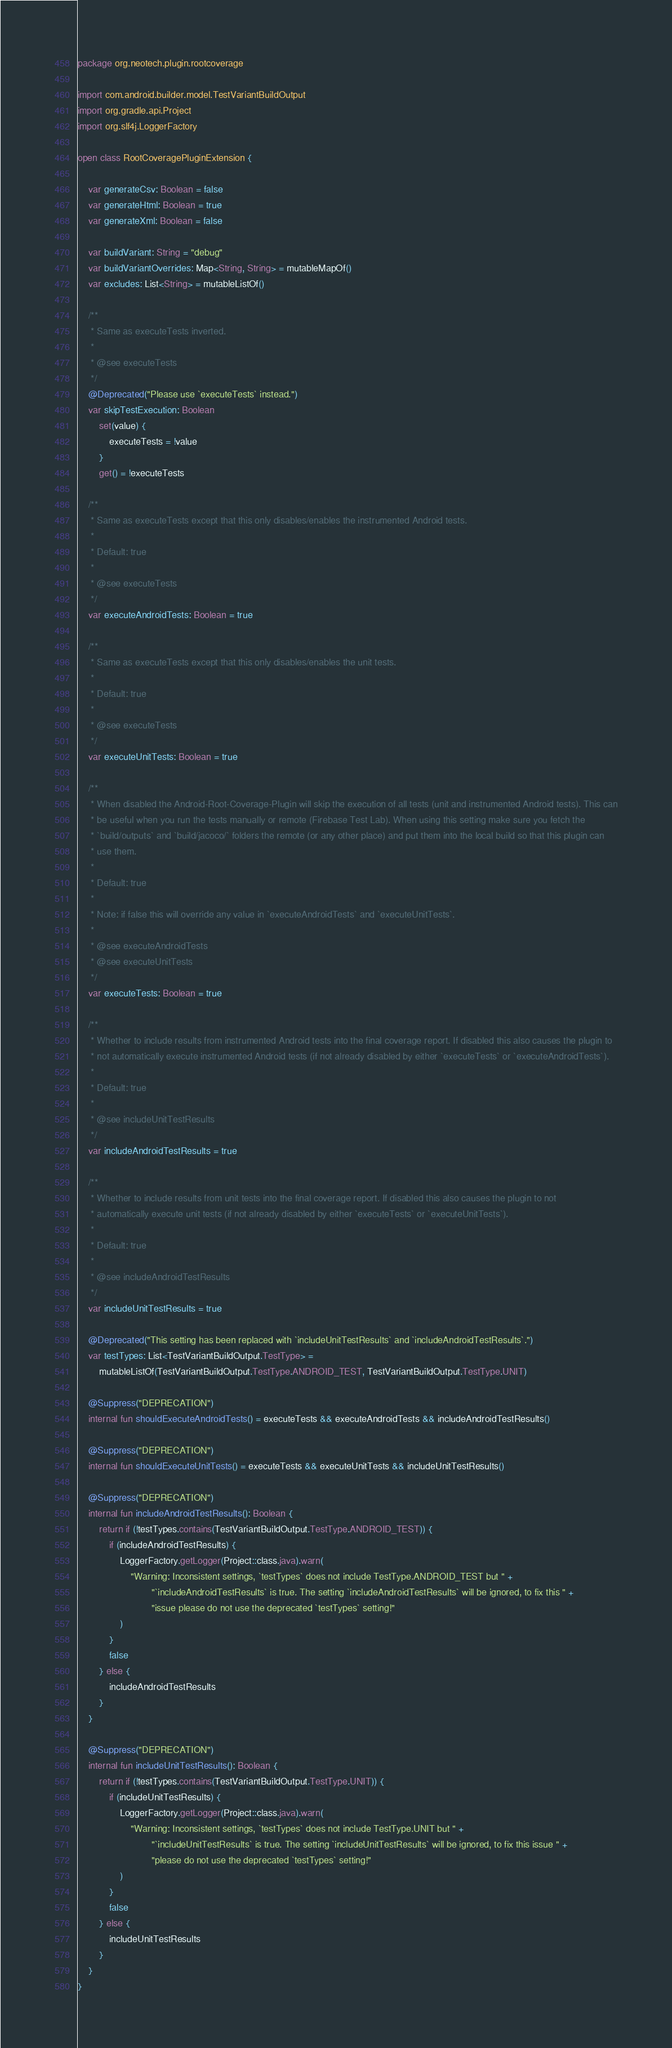Convert code to text. <code><loc_0><loc_0><loc_500><loc_500><_Kotlin_>package org.neotech.plugin.rootcoverage

import com.android.builder.model.TestVariantBuildOutput
import org.gradle.api.Project
import org.slf4j.LoggerFactory

open class RootCoveragePluginExtension {

    var generateCsv: Boolean = false
    var generateHtml: Boolean = true
    var generateXml: Boolean = false

    var buildVariant: String = "debug"
    var buildVariantOverrides: Map<String, String> = mutableMapOf()
    var excludes: List<String> = mutableListOf()

    /**
     * Same as executeTests inverted.
     *
     * @see executeTests
     */
    @Deprecated("Please use `executeTests` instead.")
    var skipTestExecution: Boolean
        set(value) {
            executeTests = !value
        }
        get() = !executeTests

    /**
     * Same as executeTests except that this only disables/enables the instrumented Android tests.
     *
     * Default: true
     *
     * @see executeTests
     */
    var executeAndroidTests: Boolean = true

    /**
     * Same as executeTests except that this only disables/enables the unit tests.
     *
     * Default: true
     *
     * @see executeTests
     */
    var executeUnitTests: Boolean = true

    /**
     * When disabled the Android-Root-Coverage-Plugin will skip the execution of all tests (unit and instrumented Android tests). This can
     * be useful when you run the tests manually or remote (Firebase Test Lab). When using this setting make sure you fetch the
     * `build/outputs` and `build/jacoco/` folders the remote (or any other place) and put them into the local build so that this plugin can
     * use them.
     *
     * Default: true
     *
     * Note: if false this will override any value in `executeAndroidTests` and `executeUnitTests`.
     *
     * @see executeAndroidTests
     * @see executeUnitTests
     */
    var executeTests: Boolean = true

    /**
     * Whether to include results from instrumented Android tests into the final coverage report. If disabled this also causes the plugin to
     * not automatically execute instrumented Android tests (if not already disabled by either `executeTests` or `executeAndroidTests`).
     *
     * Default: true
     *
     * @see includeUnitTestResults
     */
    var includeAndroidTestResults = true

    /**
     * Whether to include results from unit tests into the final coverage report. If disabled this also causes the plugin to not
     * automatically execute unit tests (if not already disabled by either `executeTests` or `executeUnitTests`).
     *
     * Default: true
     *
     * @see includeAndroidTestResults
     */
    var includeUnitTestResults = true

    @Deprecated("This setting has been replaced with `includeUnitTestResults` and `includeAndroidTestResults`.")
    var testTypes: List<TestVariantBuildOutput.TestType> =
        mutableListOf(TestVariantBuildOutput.TestType.ANDROID_TEST, TestVariantBuildOutput.TestType.UNIT)

    @Suppress("DEPRECATION")
    internal fun shouldExecuteAndroidTests() = executeTests && executeAndroidTests && includeAndroidTestResults()

    @Suppress("DEPRECATION")
    internal fun shouldExecuteUnitTests() = executeTests && executeUnitTests && includeUnitTestResults()

    @Suppress("DEPRECATION")
    internal fun includeAndroidTestResults(): Boolean {
        return if (!testTypes.contains(TestVariantBuildOutput.TestType.ANDROID_TEST)) {
            if (includeAndroidTestResults) {
                LoggerFactory.getLogger(Project::class.java).warn(
                    "Warning: Inconsistent settings, `testTypes` does not include TestType.ANDROID_TEST but " +
                            "`includeAndroidTestResults` is true. The setting `includeAndroidTestResults` will be ignored, to fix this " +
                            "issue please do not use the deprecated `testTypes` setting!"
                )
            }
            false
        } else {
            includeAndroidTestResults
        }
    }

    @Suppress("DEPRECATION")
    internal fun includeUnitTestResults(): Boolean {
        return if (!testTypes.contains(TestVariantBuildOutput.TestType.UNIT)) {
            if (includeUnitTestResults) {
                LoggerFactory.getLogger(Project::class.java).warn(
                    "Warning: Inconsistent settings, `testTypes` does not include TestType.UNIT but " +
                            "`includeUnitTestResults` is true. The setting `includeUnitTestResults` will be ignored, to fix this issue " +
                            "please do not use the deprecated `testTypes` setting!"
                )
            }
            false
        } else {
            includeUnitTestResults
        }
    }
}
</code> 